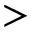Convert formula to latex. <formula><loc_0><loc_0><loc_500><loc_500>></formula> 